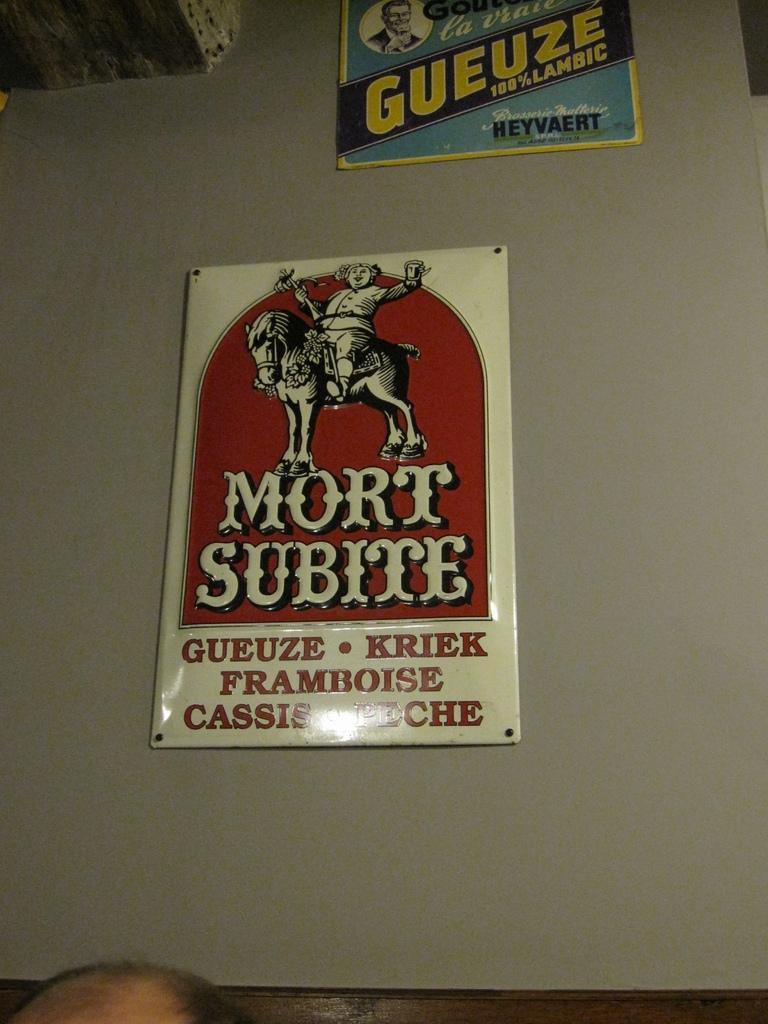Please provide a concise description of this image. In the image we can see a poster, in the poster there is an animated person and horse, and this is a printed text. We can even see a human head. 